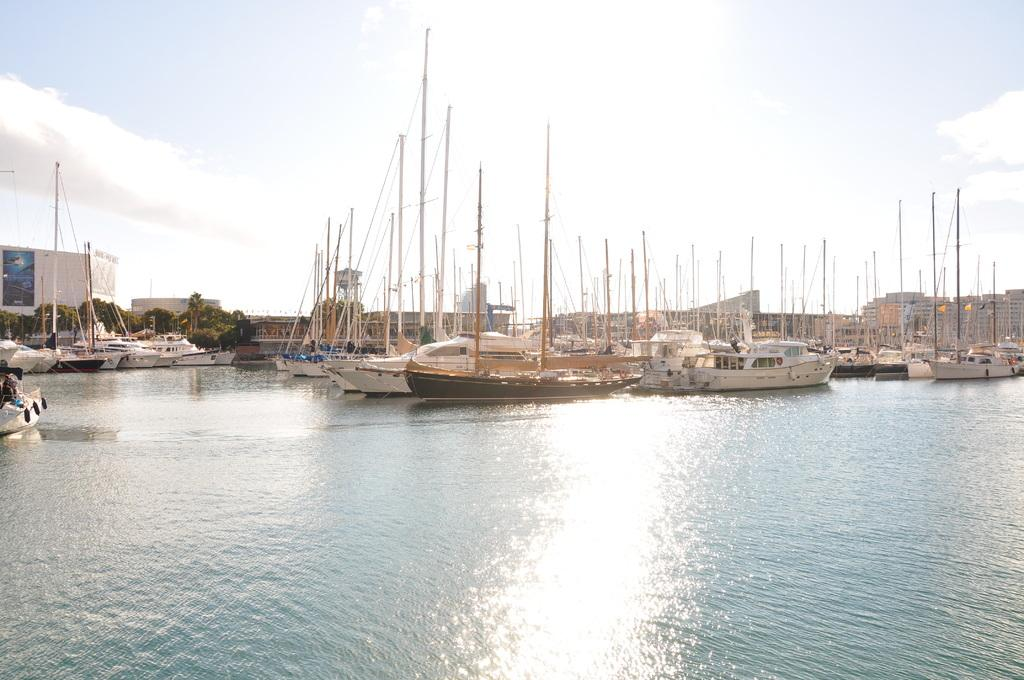What can be seen in the lake in the image? There are many ships in the lake in the image. What is visible in the background of the image? There are buildings in the background of the image. What type of vegetation is on the left side of the image? There are trees on the left side of the image. What is visible at the top of the image? The sky is visible in the image, and clouds are present in the sky. What type of shirt is the animal wearing in the image? There is no animal present in the image, and therefore no shirt or clothing can be observed. 